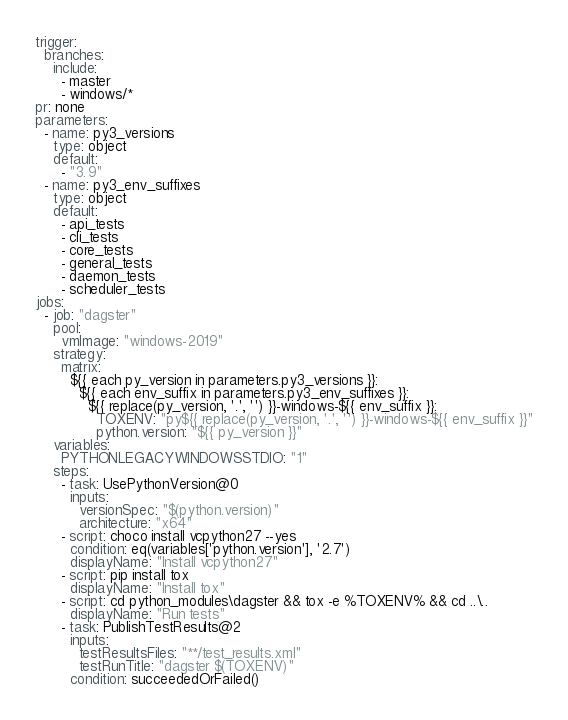<code> <loc_0><loc_0><loc_500><loc_500><_YAML_>trigger:
  branches:
    include:
      - master
      - windows/*
pr: none
parameters:
  - name: py3_versions
    type: object
    default:
      - "3.9"
  - name: py3_env_suffixes
    type: object
    default:
      - api_tests
      - cli_tests
      - core_tests
      - general_tests
      - daemon_tests
      - scheduler_tests
jobs:
  - job: "dagster"
    pool:
      vmImage: "windows-2019"
    strategy:
      matrix:
        ${{ each py_version in parameters.py3_versions }}:
          ${{ each env_suffix in parameters.py3_env_suffixes }}:
            ${{ replace(py_version, '.', '') }}-windows-${{ env_suffix }}:
              TOXENV: "py${{ replace(py_version, '.', '') }}-windows-${{ env_suffix }}"
              python.version: "${{ py_version }}"
    variables:
      PYTHONLEGACYWINDOWSSTDIO: "1"
    steps:
      - task: UsePythonVersion@0
        inputs:
          versionSpec: "$(python.version)"
          architecture: "x64"
      - script: choco install vcpython27 --yes
        condition: eq(variables['python.version'], '2.7')
        displayName: "Install vcpython27"
      - script: pip install tox
        displayName: "Install tox"
      - script: cd python_modules\dagster && tox -e %TOXENV% && cd ..\..
        displayName: "Run tests"
      - task: PublishTestResults@2
        inputs:
          testResultsFiles: "**/test_results.xml"
          testRunTitle: "dagster $(TOXENV)"
        condition: succeededOrFailed()
</code> 